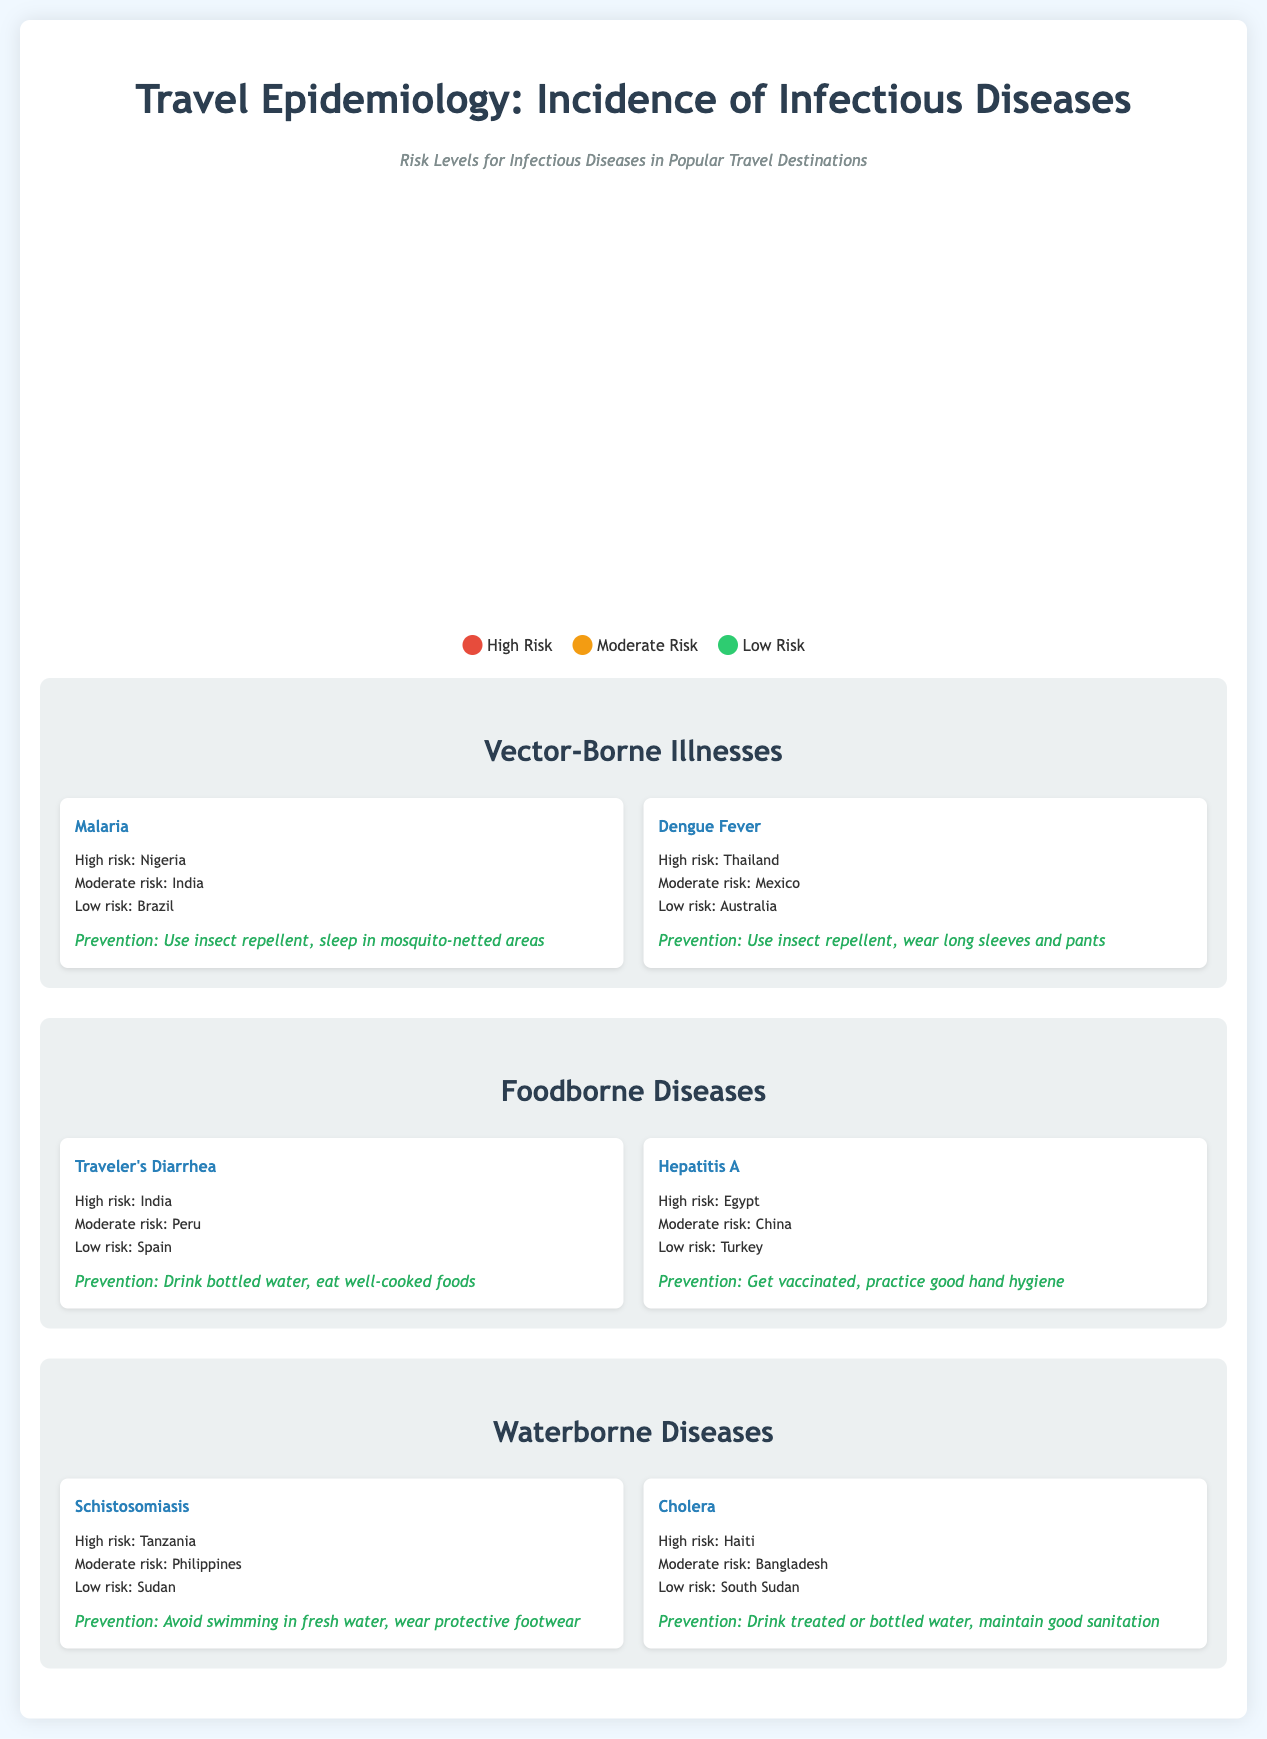what is the high-risk country for Malaria? The document lists Nigeria as a high-risk area for Malaria.
Answer: Nigeria which disease has a moderate risk in Peru? The document states that Traveler's Diarrhea has a moderate risk in Peru.
Answer: Traveler's Diarrhea what is the prevention method for Cholera? The document indicates that drinking treated or bottled water and maintaining good sanitation is a prevention method for Cholera.
Answer: Drink treated or bottled water how many diseases are classified under Waterborne Diseases? The document lists two diseases under Waterborne Diseases: Schistosomiasis and Cholera, adding up to two diseases.
Answer: 2 which country has a low risk of Hepatitis A? Turkey is identified as having a low risk of Hepatitis A in the document.
Answer: Turkey which disease has the highest risk in Haiti? The document indicates that Cholera is the disease with the highest risk in Haiti.
Answer: Cholera what is the risk level of Dengue Fever in Thailand? According to the document, Thailand is classified as having a high risk of Dengue Fever.
Answer: High risk how many countries have high-risk classification for Schistosomiasis? The document identifies one country (Tanzania) with a high-risk classification for Schistosomiasis, but also mentions countries with other risk levels, totaling one for high risk.
Answer: 1 